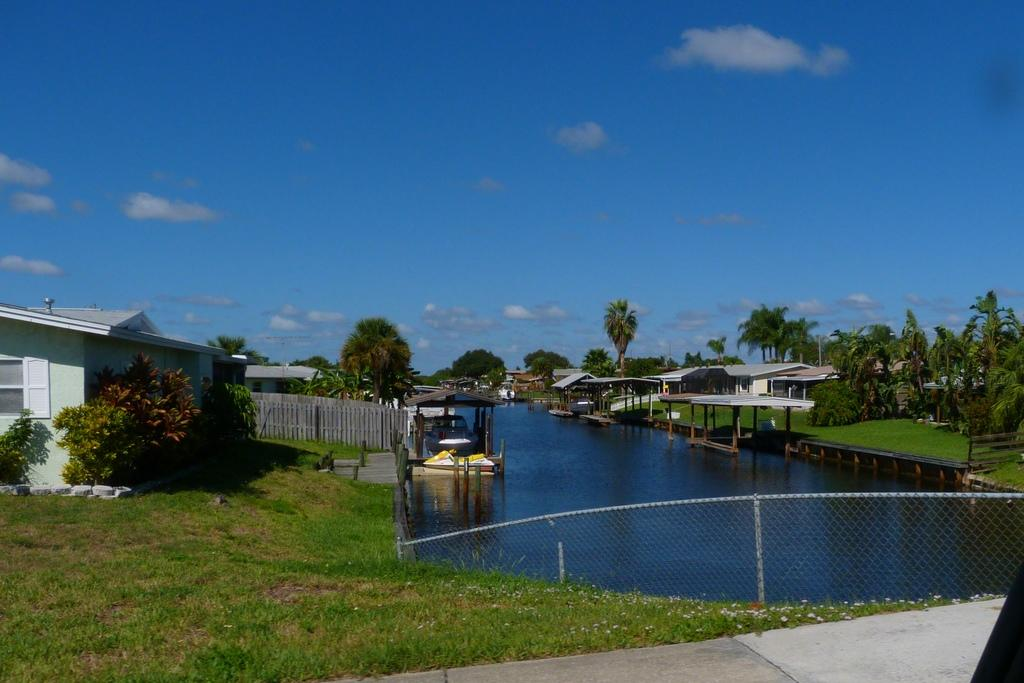What type of barrier can be seen in the image? There is a fence in the image. What is located in the center of the image? There is water in the center of the image. What type of vegetation is present in the image? There is grass and plants in the image. What structures can be seen on either side of the image? There are buildings on either side of the image. What is visible at the top of the image? The sky is visible at the top of the image. Can you see the maid's tongue in the image? There is no maid or tongue present in the image. What type of sheet is covering the plants in the image? There is no sheet covering the plants in the image; the plants are visible. 